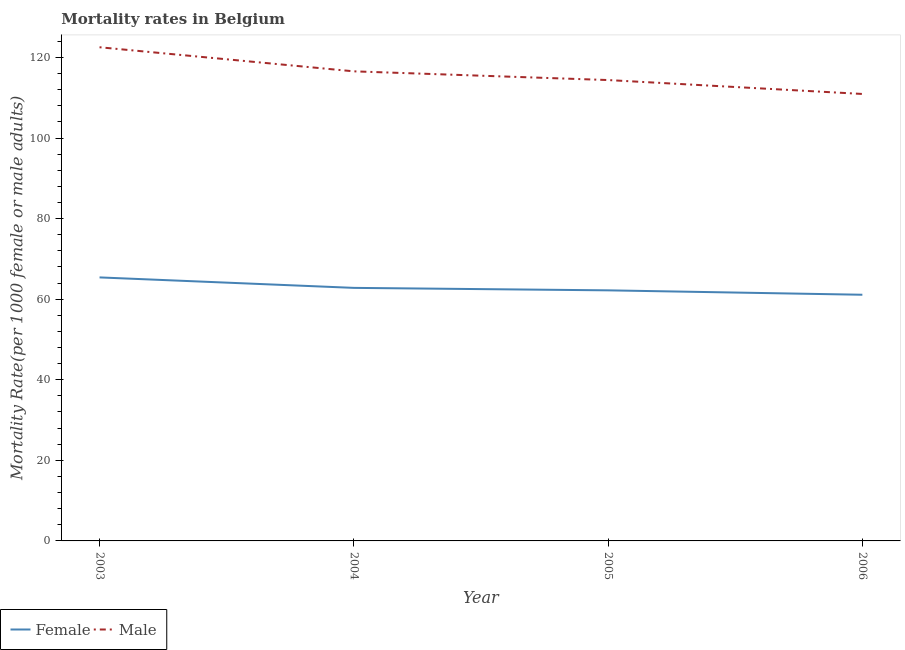Is the number of lines equal to the number of legend labels?
Provide a short and direct response. Yes. What is the female mortality rate in 2003?
Your response must be concise. 65.41. Across all years, what is the maximum female mortality rate?
Give a very brief answer. 65.41. Across all years, what is the minimum male mortality rate?
Provide a succinct answer. 110.94. In which year was the female mortality rate minimum?
Your answer should be very brief. 2006. What is the total male mortality rate in the graph?
Your answer should be compact. 464.41. What is the difference between the female mortality rate in 2005 and that in 2006?
Your response must be concise. 1.09. What is the difference between the male mortality rate in 2004 and the female mortality rate in 2006?
Your answer should be very brief. 55.45. What is the average female mortality rate per year?
Your response must be concise. 62.88. In the year 2003, what is the difference between the male mortality rate and female mortality rate?
Offer a terse response. 57.12. What is the ratio of the female mortality rate in 2003 to that in 2004?
Give a very brief answer. 1.04. Is the difference between the female mortality rate in 2004 and 2006 greater than the difference between the male mortality rate in 2004 and 2006?
Your response must be concise. No. What is the difference between the highest and the second highest female mortality rate?
Your answer should be very brief. 2.6. What is the difference between the highest and the lowest female mortality rate?
Your response must be concise. 4.31. Is the sum of the male mortality rate in 2004 and 2005 greater than the maximum female mortality rate across all years?
Make the answer very short. Yes. Does the female mortality rate monotonically increase over the years?
Offer a very short reply. No. What is the difference between two consecutive major ticks on the Y-axis?
Give a very brief answer. 20. Are the values on the major ticks of Y-axis written in scientific E-notation?
Offer a very short reply. No. Does the graph contain grids?
Your answer should be very brief. No. How are the legend labels stacked?
Your answer should be compact. Horizontal. What is the title of the graph?
Keep it short and to the point. Mortality rates in Belgium. What is the label or title of the Y-axis?
Offer a very short reply. Mortality Rate(per 1000 female or male adults). What is the Mortality Rate(per 1000 female or male adults) in Female in 2003?
Keep it short and to the point. 65.41. What is the Mortality Rate(per 1000 female or male adults) in Male in 2003?
Provide a succinct answer. 122.53. What is the Mortality Rate(per 1000 female or male adults) of Female in 2004?
Offer a terse response. 62.81. What is the Mortality Rate(per 1000 female or male adults) in Male in 2004?
Keep it short and to the point. 116.55. What is the Mortality Rate(per 1000 female or male adults) of Female in 2005?
Offer a terse response. 62.2. What is the Mortality Rate(per 1000 female or male adults) in Male in 2005?
Your answer should be compact. 114.39. What is the Mortality Rate(per 1000 female or male adults) in Female in 2006?
Give a very brief answer. 61.1. What is the Mortality Rate(per 1000 female or male adults) of Male in 2006?
Your answer should be compact. 110.94. Across all years, what is the maximum Mortality Rate(per 1000 female or male adults) in Female?
Provide a short and direct response. 65.41. Across all years, what is the maximum Mortality Rate(per 1000 female or male adults) of Male?
Ensure brevity in your answer.  122.53. Across all years, what is the minimum Mortality Rate(per 1000 female or male adults) in Female?
Offer a very short reply. 61.1. Across all years, what is the minimum Mortality Rate(per 1000 female or male adults) in Male?
Offer a terse response. 110.94. What is the total Mortality Rate(per 1000 female or male adults) in Female in the graph?
Give a very brief answer. 251.51. What is the total Mortality Rate(per 1000 female or male adults) of Male in the graph?
Your answer should be very brief. 464.41. What is the difference between the Mortality Rate(per 1000 female or male adults) in Female in 2003 and that in 2004?
Keep it short and to the point. 2.6. What is the difference between the Mortality Rate(per 1000 female or male adults) in Male in 2003 and that in 2004?
Give a very brief answer. 5.98. What is the difference between the Mortality Rate(per 1000 female or male adults) in Female in 2003 and that in 2005?
Offer a very short reply. 3.21. What is the difference between the Mortality Rate(per 1000 female or male adults) in Male in 2003 and that in 2005?
Your answer should be very brief. 8.14. What is the difference between the Mortality Rate(per 1000 female or male adults) of Female in 2003 and that in 2006?
Provide a succinct answer. 4.31. What is the difference between the Mortality Rate(per 1000 female or male adults) of Male in 2003 and that in 2006?
Offer a terse response. 11.6. What is the difference between the Mortality Rate(per 1000 female or male adults) in Female in 2004 and that in 2005?
Your response must be concise. 0.61. What is the difference between the Mortality Rate(per 1000 female or male adults) in Male in 2004 and that in 2005?
Give a very brief answer. 2.16. What is the difference between the Mortality Rate(per 1000 female or male adults) in Female in 2004 and that in 2006?
Offer a very short reply. 1.71. What is the difference between the Mortality Rate(per 1000 female or male adults) in Male in 2004 and that in 2006?
Keep it short and to the point. 5.62. What is the difference between the Mortality Rate(per 1000 female or male adults) in Female in 2005 and that in 2006?
Your answer should be compact. 1.09. What is the difference between the Mortality Rate(per 1000 female or male adults) of Male in 2005 and that in 2006?
Give a very brief answer. 3.45. What is the difference between the Mortality Rate(per 1000 female or male adults) in Female in 2003 and the Mortality Rate(per 1000 female or male adults) in Male in 2004?
Offer a terse response. -51.15. What is the difference between the Mortality Rate(per 1000 female or male adults) in Female in 2003 and the Mortality Rate(per 1000 female or male adults) in Male in 2005?
Your answer should be compact. -48.98. What is the difference between the Mortality Rate(per 1000 female or male adults) of Female in 2003 and the Mortality Rate(per 1000 female or male adults) of Male in 2006?
Your answer should be compact. -45.53. What is the difference between the Mortality Rate(per 1000 female or male adults) of Female in 2004 and the Mortality Rate(per 1000 female or male adults) of Male in 2005?
Keep it short and to the point. -51.58. What is the difference between the Mortality Rate(per 1000 female or male adults) in Female in 2004 and the Mortality Rate(per 1000 female or male adults) in Male in 2006?
Give a very brief answer. -48.13. What is the difference between the Mortality Rate(per 1000 female or male adults) of Female in 2005 and the Mortality Rate(per 1000 female or male adults) of Male in 2006?
Your response must be concise. -48.74. What is the average Mortality Rate(per 1000 female or male adults) in Female per year?
Offer a very short reply. 62.88. What is the average Mortality Rate(per 1000 female or male adults) in Male per year?
Ensure brevity in your answer.  116.1. In the year 2003, what is the difference between the Mortality Rate(per 1000 female or male adults) of Female and Mortality Rate(per 1000 female or male adults) of Male?
Offer a terse response. -57.12. In the year 2004, what is the difference between the Mortality Rate(per 1000 female or male adults) of Female and Mortality Rate(per 1000 female or male adults) of Male?
Provide a short and direct response. -53.75. In the year 2005, what is the difference between the Mortality Rate(per 1000 female or male adults) of Female and Mortality Rate(per 1000 female or male adults) of Male?
Give a very brief answer. -52.19. In the year 2006, what is the difference between the Mortality Rate(per 1000 female or male adults) of Female and Mortality Rate(per 1000 female or male adults) of Male?
Offer a very short reply. -49.84. What is the ratio of the Mortality Rate(per 1000 female or male adults) in Female in 2003 to that in 2004?
Give a very brief answer. 1.04. What is the ratio of the Mortality Rate(per 1000 female or male adults) in Male in 2003 to that in 2004?
Offer a terse response. 1.05. What is the ratio of the Mortality Rate(per 1000 female or male adults) in Female in 2003 to that in 2005?
Give a very brief answer. 1.05. What is the ratio of the Mortality Rate(per 1000 female or male adults) in Male in 2003 to that in 2005?
Offer a very short reply. 1.07. What is the ratio of the Mortality Rate(per 1000 female or male adults) of Female in 2003 to that in 2006?
Your answer should be compact. 1.07. What is the ratio of the Mortality Rate(per 1000 female or male adults) in Male in 2003 to that in 2006?
Keep it short and to the point. 1.1. What is the ratio of the Mortality Rate(per 1000 female or male adults) in Female in 2004 to that in 2005?
Your answer should be very brief. 1.01. What is the ratio of the Mortality Rate(per 1000 female or male adults) of Male in 2004 to that in 2005?
Offer a very short reply. 1.02. What is the ratio of the Mortality Rate(per 1000 female or male adults) in Female in 2004 to that in 2006?
Keep it short and to the point. 1.03. What is the ratio of the Mortality Rate(per 1000 female or male adults) of Male in 2004 to that in 2006?
Your answer should be very brief. 1.05. What is the ratio of the Mortality Rate(per 1000 female or male adults) of Female in 2005 to that in 2006?
Give a very brief answer. 1.02. What is the ratio of the Mortality Rate(per 1000 female or male adults) of Male in 2005 to that in 2006?
Your response must be concise. 1.03. What is the difference between the highest and the second highest Mortality Rate(per 1000 female or male adults) of Female?
Provide a short and direct response. 2.6. What is the difference between the highest and the second highest Mortality Rate(per 1000 female or male adults) in Male?
Provide a succinct answer. 5.98. What is the difference between the highest and the lowest Mortality Rate(per 1000 female or male adults) of Female?
Provide a succinct answer. 4.31. What is the difference between the highest and the lowest Mortality Rate(per 1000 female or male adults) in Male?
Make the answer very short. 11.6. 